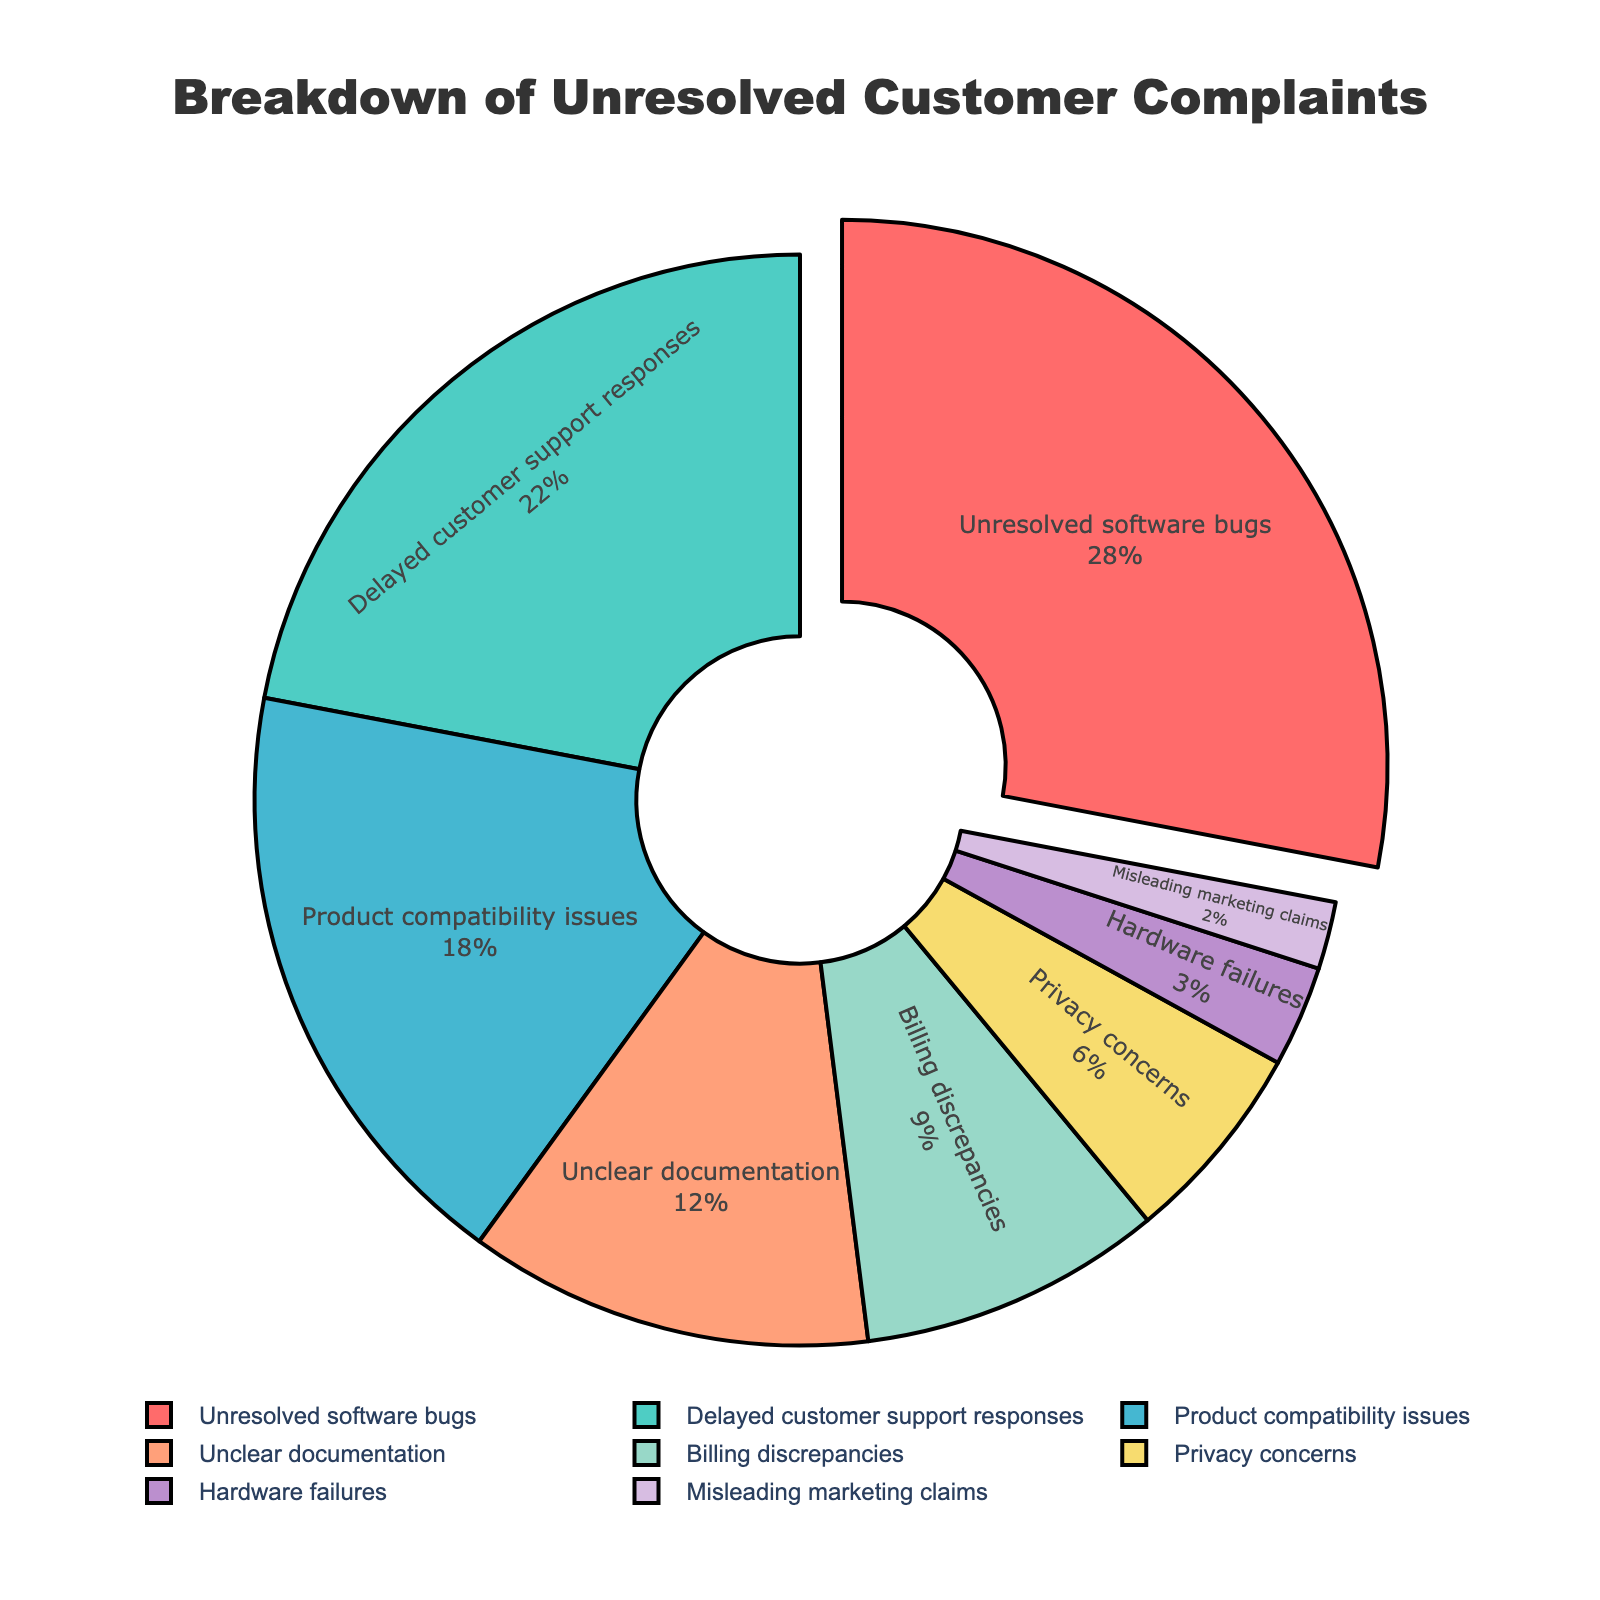What category has the highest percentage of unresolved complaints? The slice on the pie chart pulled out is marked "Unresolved software bugs" and has the largest percentage labeled as 28%.
Answer: Unresolved software bugs What is the combined percentage of complaints related to customer support and product compatibility? Sum the percentages for "Delayed customer support responses" (22%) and "Product compatibility issues" (18%): 22% + 18% = 40%.
Answer: 40% How does the percentage of billing discrepancies compare to privacy concerns? The chart shows "Billing discrepancies" at 9% and "Privacy concerns" at 6%. Thus, billing discrepancies are greater than privacy concerns by 3%.
Answer: Billing discrepancies are 3% higher What are the three smallest categories in terms of percentage? The pie chart shows the smallest slices: "Misleading marketing claims" (2%), "Hardware failures" (3%), and "Privacy concerns" (6%).
Answer: Misleading marketing claims, Hardware failures, Privacy concerns What is the total percentage of unresolved software bugs, delayed customer support responses, and unclear documentation complaints? Sum the percentages for "Unresolved software bugs" (28%), "Delayed customer support responses" (22%), and "Unclear documentation" (12%): 28% + 22% + 12% = 62%.
Answer: 62% Which categories have a percentage greater than 15%? The pie chart shows "Unresolved software bugs" (28%), "Delayed customer support responses" (22%), and "Product compatibility issues" (18%) all above 15%.
Answer: Unresolved software bugs, Delayed customer support responses, Product compatibility issues How does the portion representing product compatibility issues visually compare to that of unclear documentation? Visually, the "Product compatibility issues" slice is significantly larger than the "Unclear documentation" slice, indicating it has a larger percentage (18% vs. 12%).
Answer: Product compatibility issues is larger 